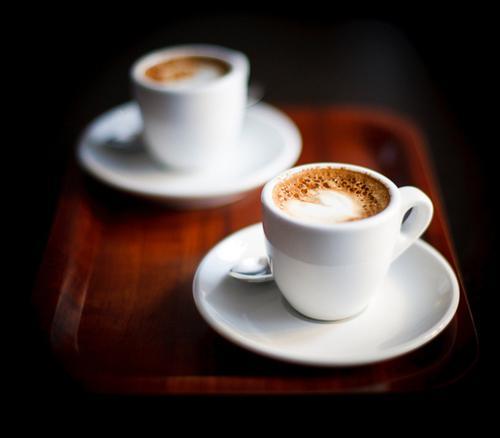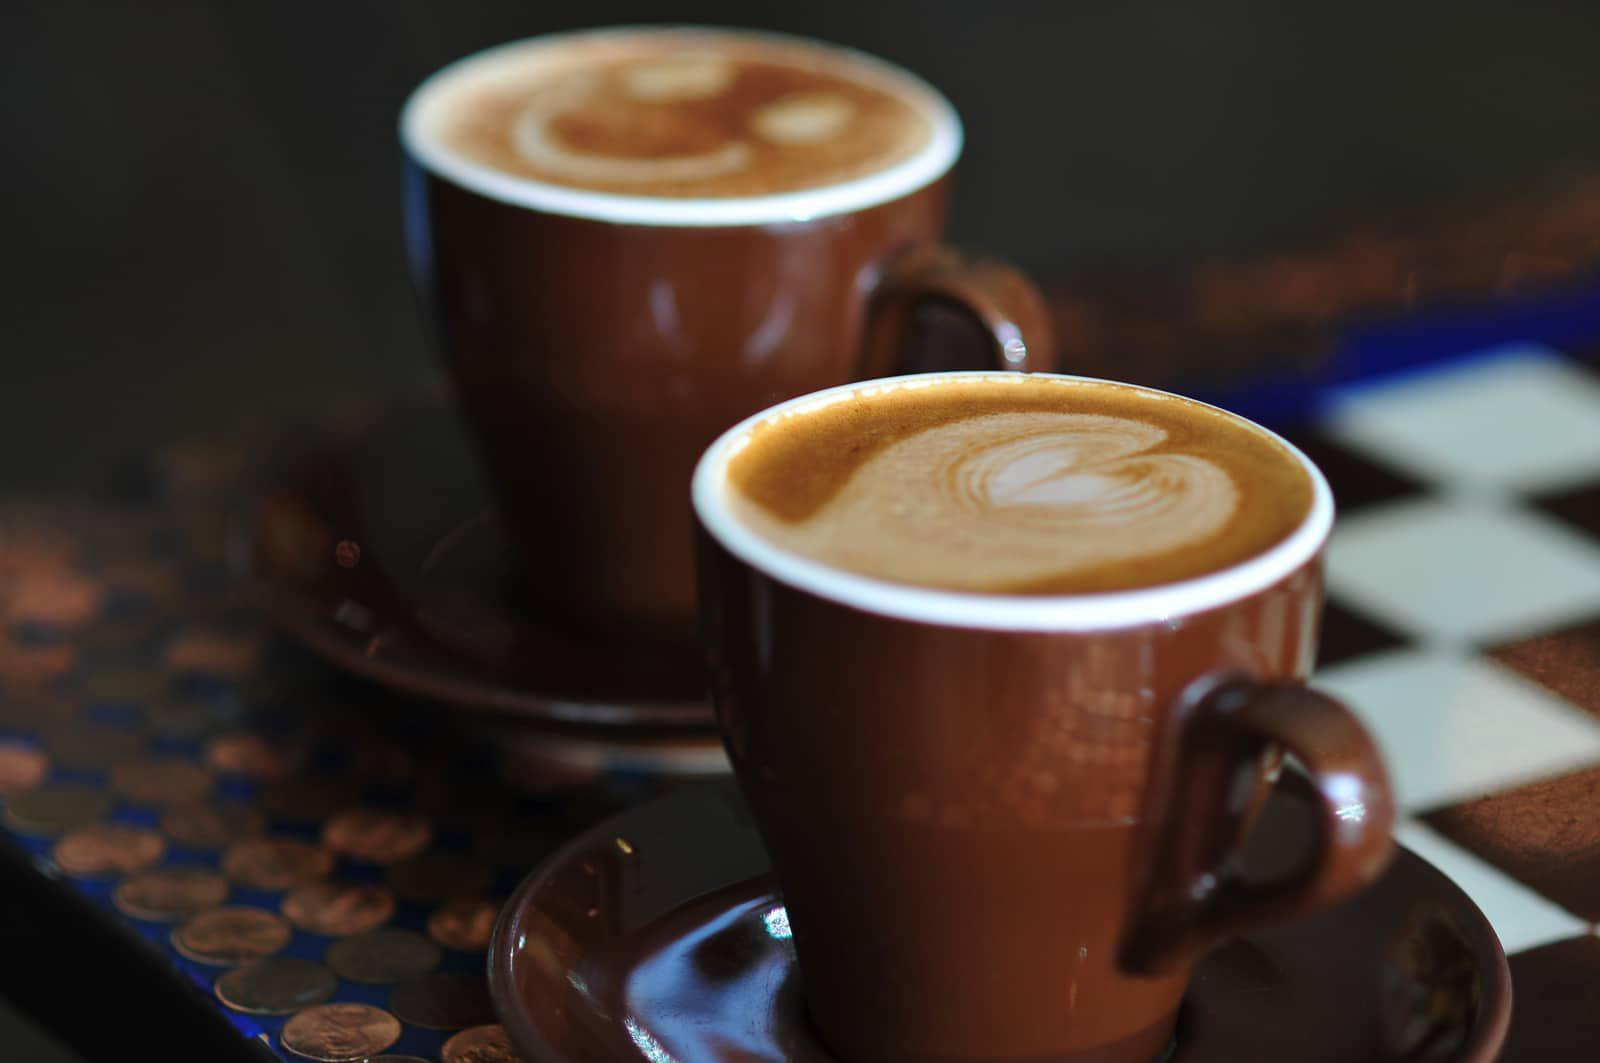The first image is the image on the left, the second image is the image on the right. Examine the images to the left and right. Is the description "One image shows human hands wrapped around a cup." accurate? Answer yes or no. No. The first image is the image on the left, the second image is the image on the right. For the images displayed, is the sentence "Only one image includes human hands with mugs of hot beverages." factually correct? Answer yes or no. No. 